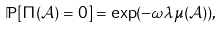Convert formula to latex. <formula><loc_0><loc_0><loc_500><loc_500>\mathbb { P } [ \Pi ( \mathcal { A } ) = 0 ] = \exp ( - \omega \lambda \mu ( \mathcal { A } ) ) ,</formula> 